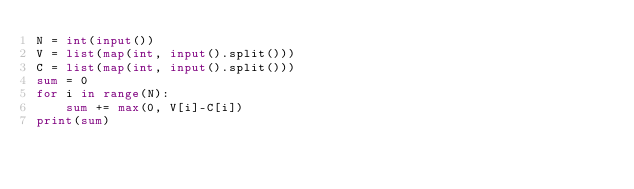Convert code to text. <code><loc_0><loc_0><loc_500><loc_500><_Python_>N = int(input())
V = list(map(int, input().split()))
C = list(map(int, input().split()))
sum = 0
for i in range(N):
    sum += max(0, V[i]-C[i])
print(sum)</code> 